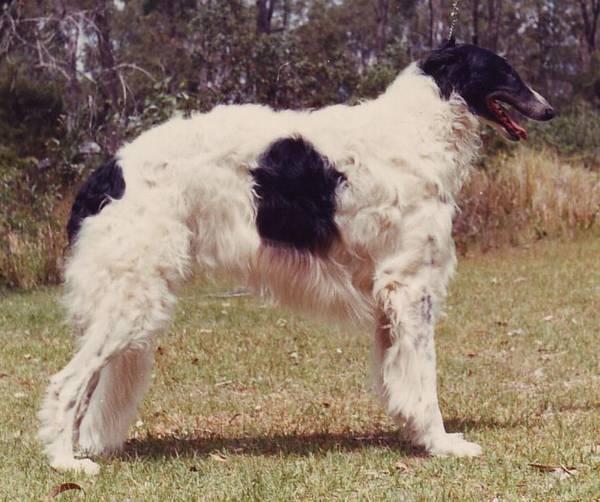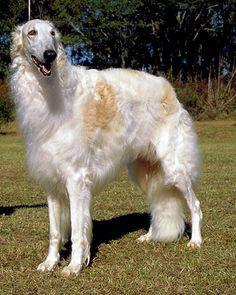The first image is the image on the left, the second image is the image on the right. Examine the images to the left and right. Is the description "At least one dog has its mouth open." accurate? Answer yes or no. Yes. 